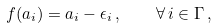<formula> <loc_0><loc_0><loc_500><loc_500>f ( a _ { i } ) = a _ { i } - \epsilon _ { i } \, , \quad \forall \, i \in \Gamma \, ,</formula> 